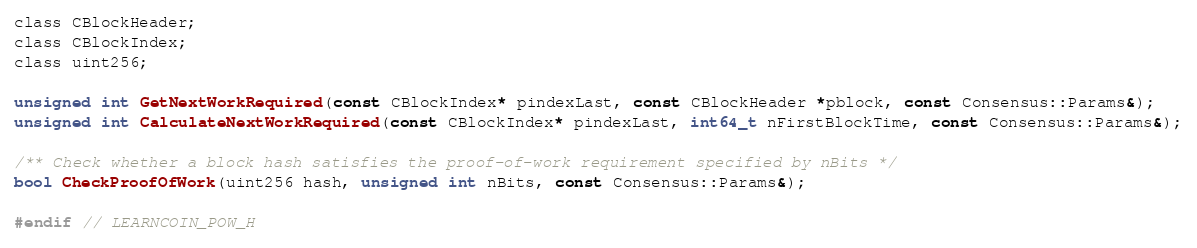<code> <loc_0><loc_0><loc_500><loc_500><_C_>class CBlockHeader;
class CBlockIndex;
class uint256;

unsigned int GetNextWorkRequired(const CBlockIndex* pindexLast, const CBlockHeader *pblock, const Consensus::Params&);
unsigned int CalculateNextWorkRequired(const CBlockIndex* pindexLast, int64_t nFirstBlockTime, const Consensus::Params&);

/** Check whether a block hash satisfies the proof-of-work requirement specified by nBits */
bool CheckProofOfWork(uint256 hash, unsigned int nBits, const Consensus::Params&);

#endif // LEARNCOIN_POW_H
</code> 